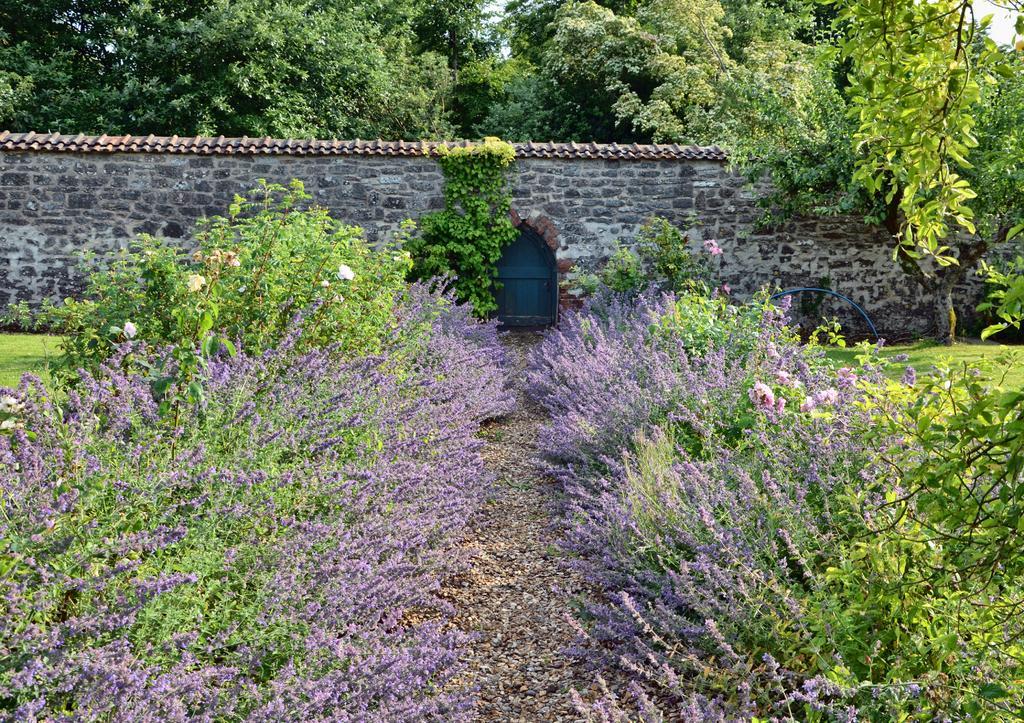Can you describe this image briefly? There are lavender flower plants. There is grass on the either sides and a walkway at the center. There is a stone wall house at the back which has a roof and a blue door at the center. There are trees at the back. 